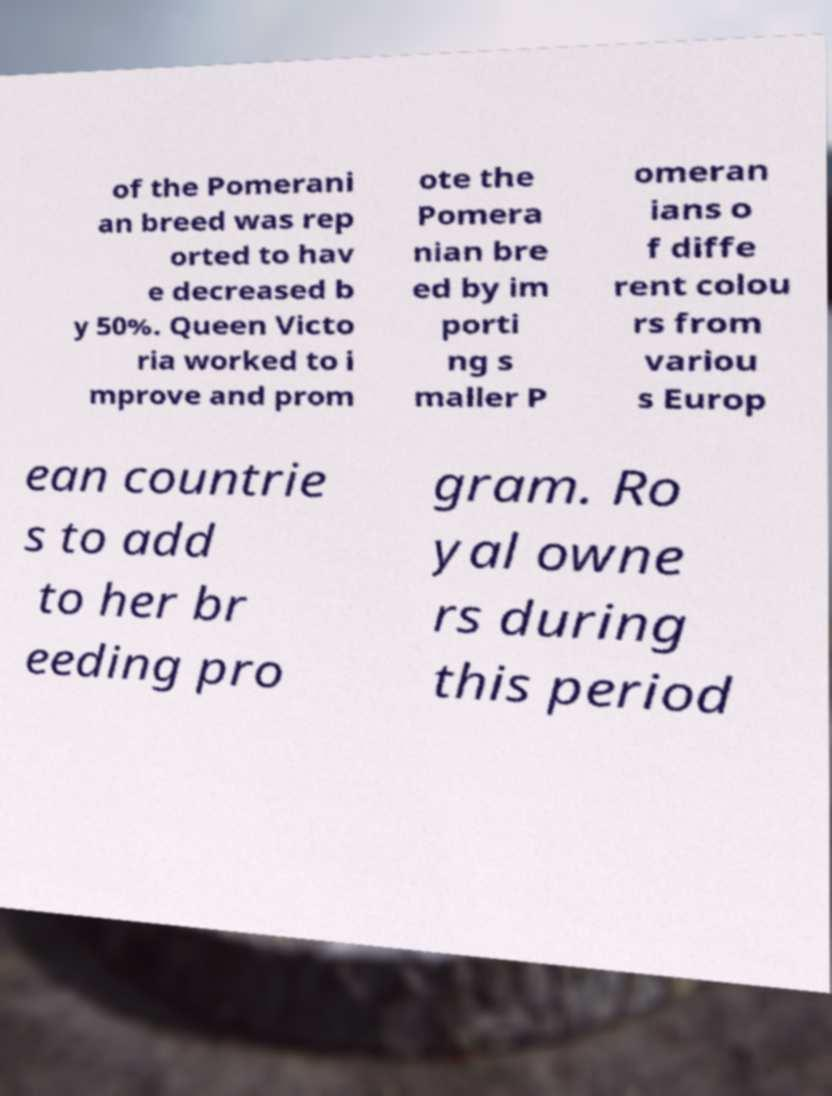For documentation purposes, I need the text within this image transcribed. Could you provide that? of the Pomerani an breed was rep orted to hav e decreased b y 50%. Queen Victo ria worked to i mprove and prom ote the Pomera nian bre ed by im porti ng s maller P omeran ians o f diffe rent colou rs from variou s Europ ean countrie s to add to her br eeding pro gram. Ro yal owne rs during this period 